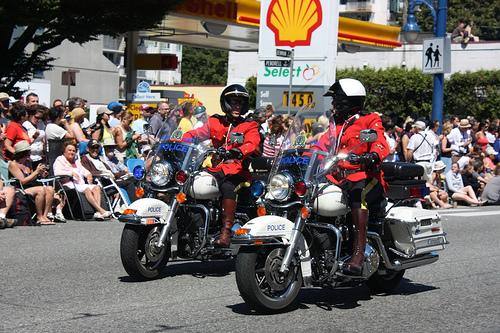What do the people seated by the road await? parade 